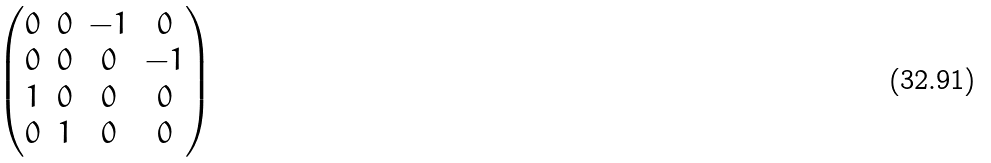<formula> <loc_0><loc_0><loc_500><loc_500>\begin{pmatrix} 0 & 0 & - 1 & 0 \\ 0 & 0 & 0 & - 1 \\ 1 & 0 & 0 & 0 \\ 0 & 1 & 0 & 0 \end{pmatrix}</formula> 